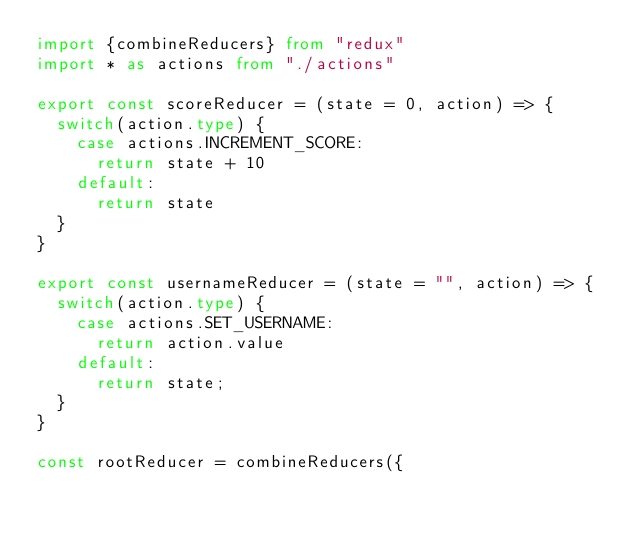<code> <loc_0><loc_0><loc_500><loc_500><_TypeScript_>import {combineReducers} from "redux"
import * as actions from "./actions"

export const scoreReducer = (state = 0, action) => {
  switch(action.type) {
    case actions.INCREMENT_SCORE:
      return state + 10
    default:
      return state
  }
}

export const usernameReducer = (state = "", action) => {
  switch(action.type) {
    case actions.SET_USERNAME:
      return action.value
    default:
      return state;
  }
}

const rootReducer = combineReducers({</code> 